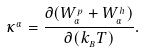Convert formula to latex. <formula><loc_0><loc_0><loc_500><loc_500>\kappa ^ { _ { \alpha } } = \frac { \partial ( W _ { _ { \alpha } } ^ { _ { p } } + W _ { _ { \alpha } } ^ { _ { h } } ) } { \partial ( k _ { _ { B } } T ) } .</formula> 